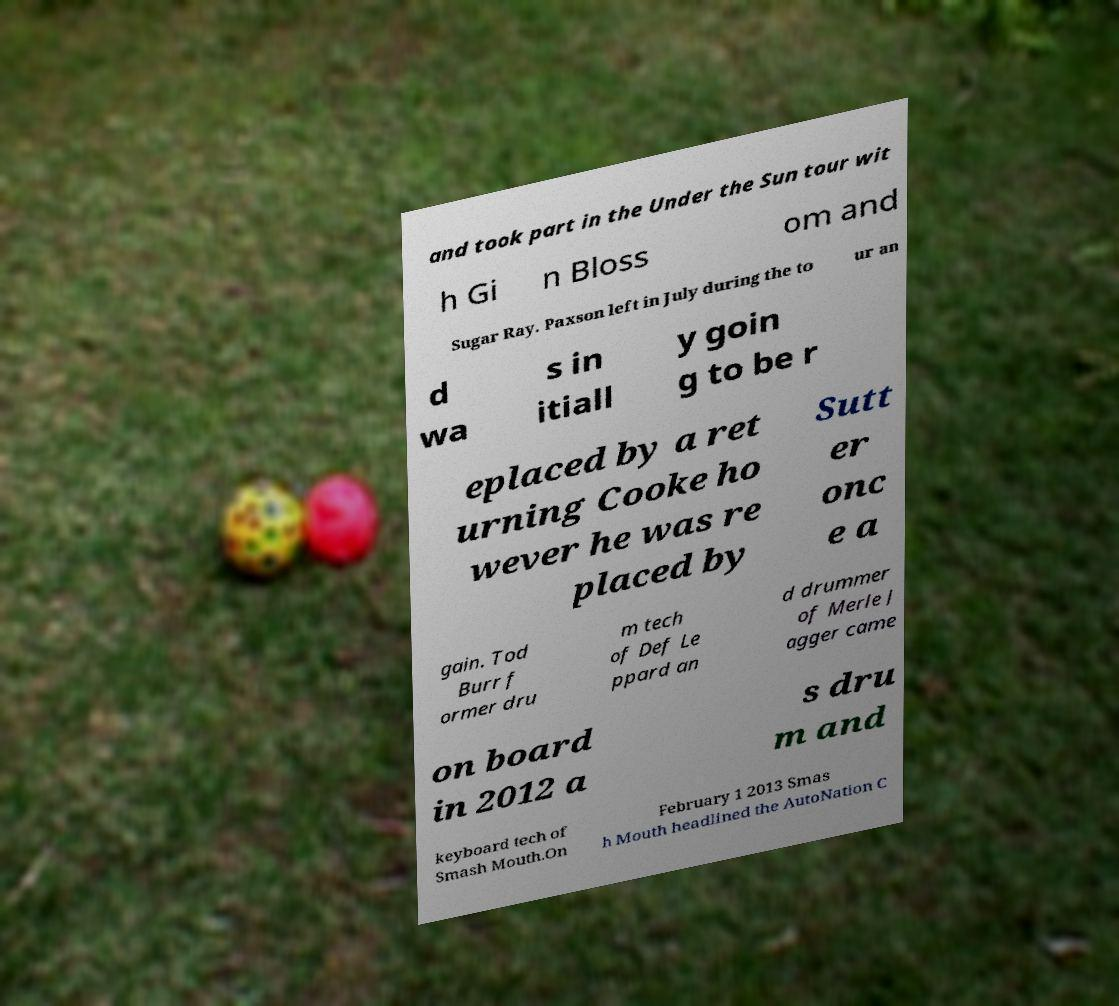There's text embedded in this image that I need extracted. Can you transcribe it verbatim? and took part in the Under the Sun tour wit h Gi n Bloss om and Sugar Ray. Paxson left in July during the to ur an d wa s in itiall y goin g to be r eplaced by a ret urning Cooke ho wever he was re placed by Sutt er onc e a gain. Tod Burr f ormer dru m tech of Def Le ppard an d drummer of Merle J agger came on board in 2012 a s dru m and keyboard tech of Smash Mouth.On February 1 2013 Smas h Mouth headlined the AutoNation C 